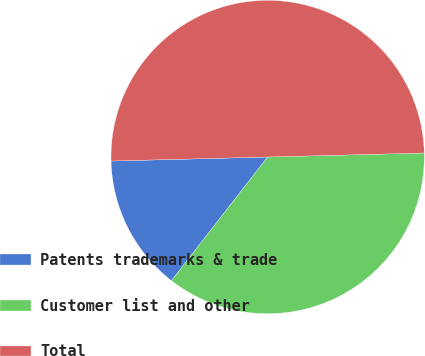Convert chart. <chart><loc_0><loc_0><loc_500><loc_500><pie_chart><fcel>Patents trademarks & trade<fcel>Customer list and other<fcel>Total<nl><fcel>14.07%<fcel>35.93%<fcel>50.0%<nl></chart> 